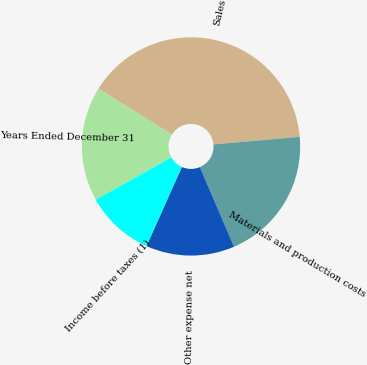Convert chart to OTSL. <chart><loc_0><loc_0><loc_500><loc_500><pie_chart><fcel>Years Ended December 31<fcel>Sales<fcel>Materials and production costs<fcel>Other expense net<fcel>Income before taxes (1)<nl><fcel>17.01%<fcel>39.69%<fcel>19.96%<fcel>13.14%<fcel>10.19%<nl></chart> 